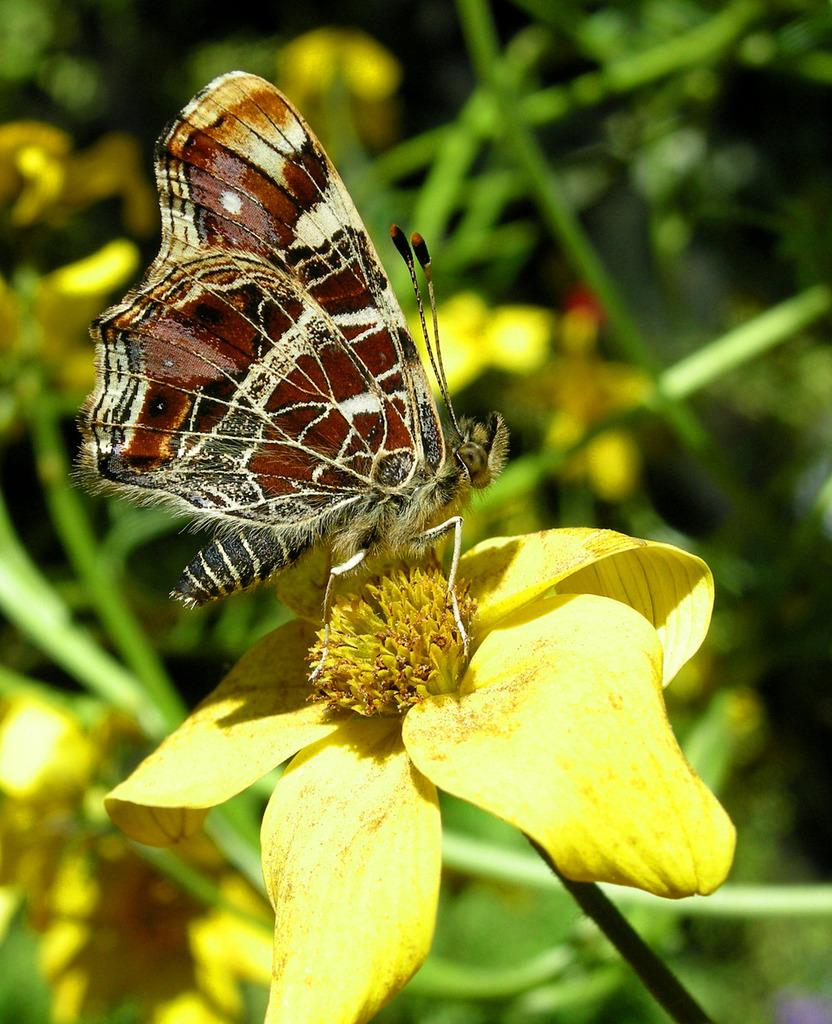What is on the flower in the image? There is a butterfly on a flower in the image. What color is the flower with the butterfly? The flower is yellow. What can be seen in the background of the image? There are plants and flowers in the background of the image. How many chairs are visible in the image? There are no chairs present in the image. What question is being asked in the image? There is no question being asked in the image; it is a photograph of a butterfly on a yellow flower with plants and flowers in the background. 